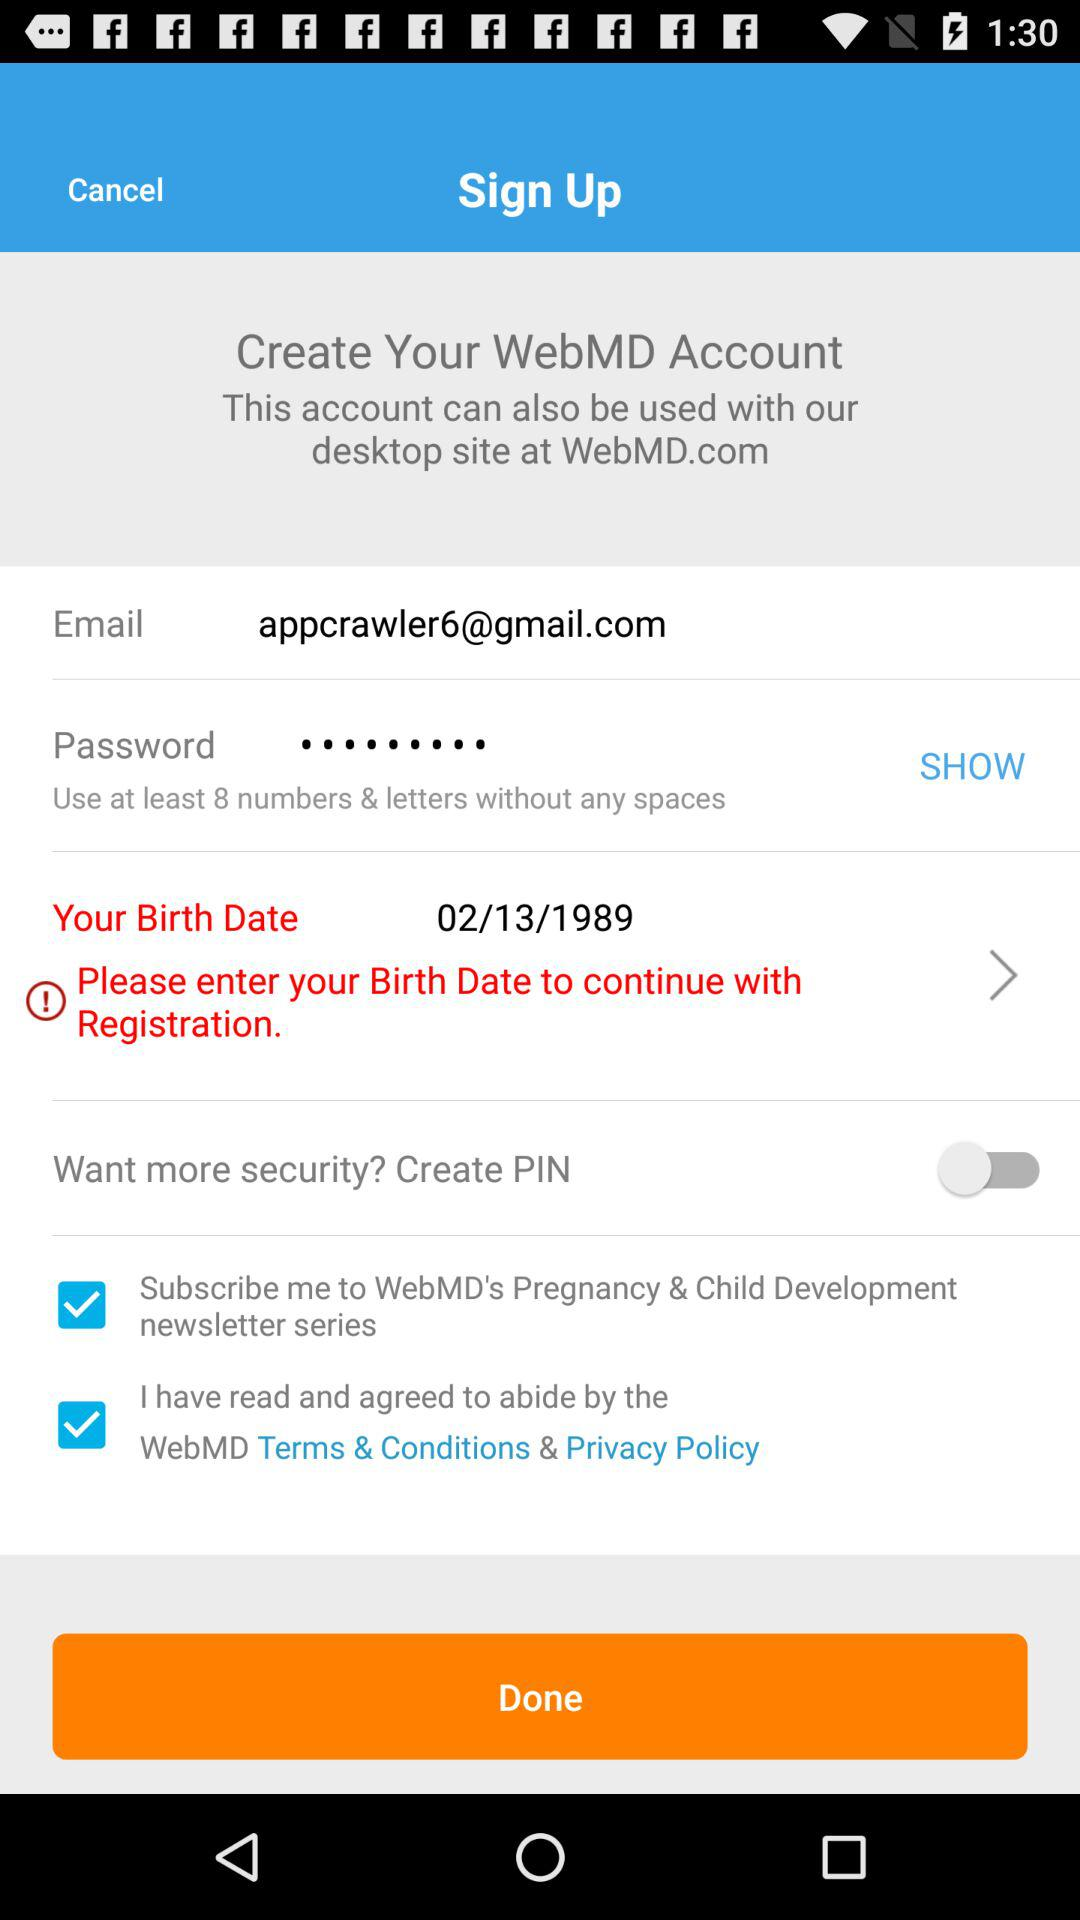How many more check boxes are there than switches?
Answer the question using a single word or phrase. 1 